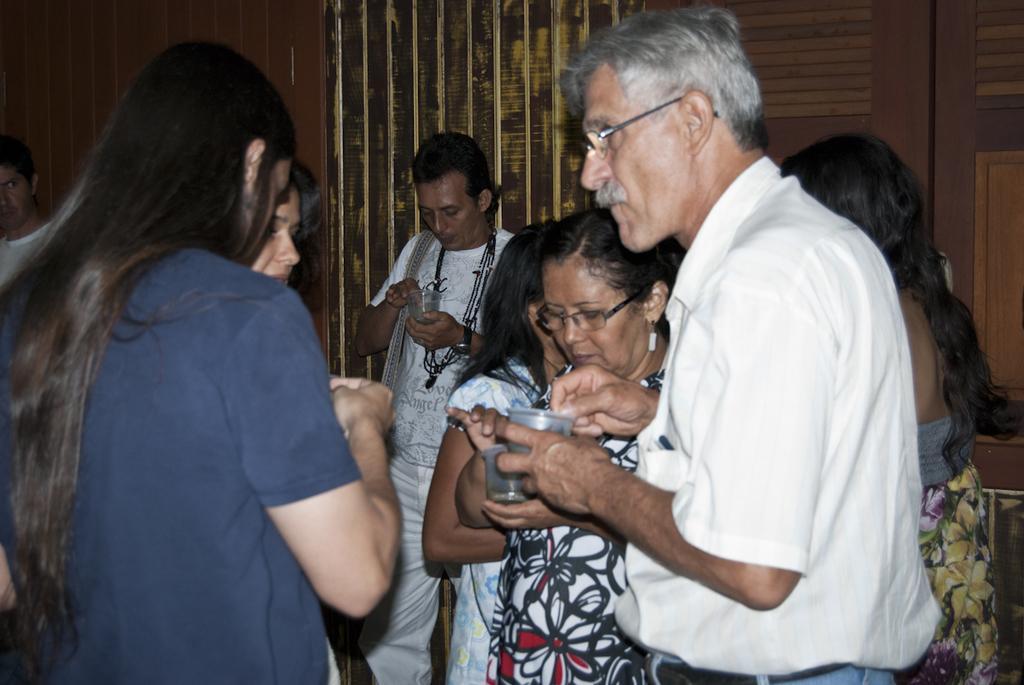Please provide a concise description of this image. In this image we can see a few people, some of them are holding cups, there is a closet, and the wall. 